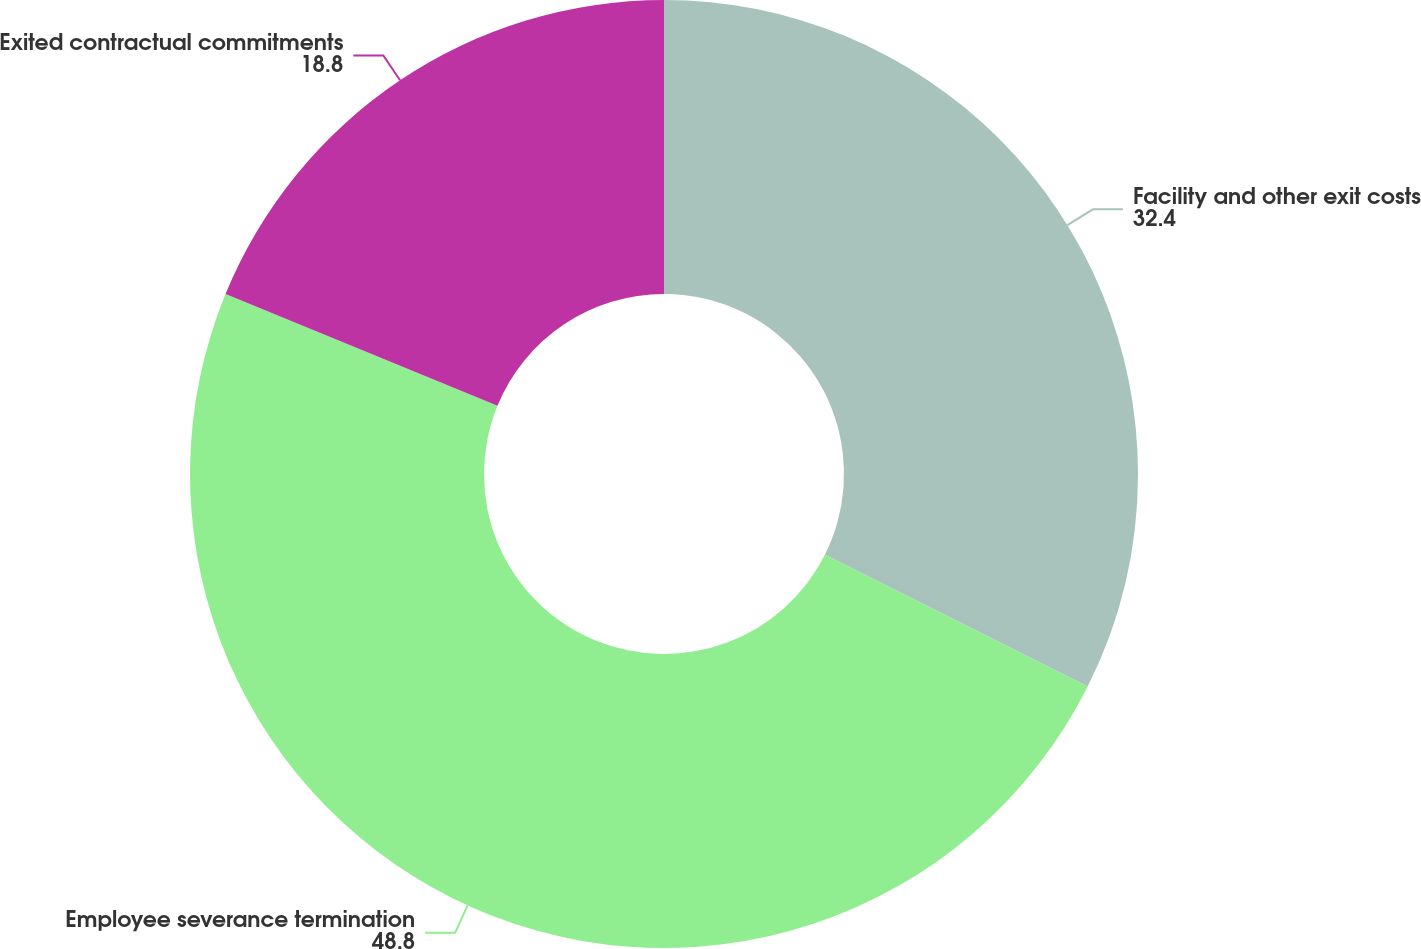Convert chart. <chart><loc_0><loc_0><loc_500><loc_500><pie_chart><fcel>Facility and other exit costs<fcel>Employee severance termination<fcel>Exited contractual commitments<nl><fcel>32.4%<fcel>48.8%<fcel>18.8%<nl></chart> 